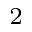Convert formula to latex. <formula><loc_0><loc_0><loc_500><loc_500>_ { 2 }</formula> 